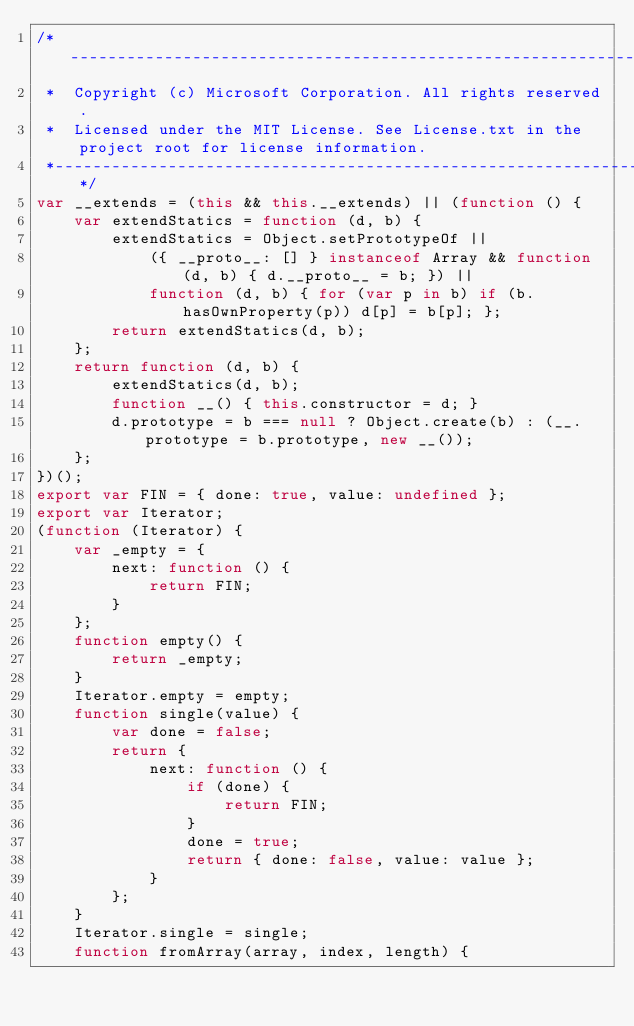<code> <loc_0><loc_0><loc_500><loc_500><_JavaScript_>/*---------------------------------------------------------------------------------------------
 *  Copyright (c) Microsoft Corporation. All rights reserved.
 *  Licensed under the MIT License. See License.txt in the project root for license information.
 *--------------------------------------------------------------------------------------------*/
var __extends = (this && this.__extends) || (function () {
    var extendStatics = function (d, b) {
        extendStatics = Object.setPrototypeOf ||
            ({ __proto__: [] } instanceof Array && function (d, b) { d.__proto__ = b; }) ||
            function (d, b) { for (var p in b) if (b.hasOwnProperty(p)) d[p] = b[p]; };
        return extendStatics(d, b);
    };
    return function (d, b) {
        extendStatics(d, b);
        function __() { this.constructor = d; }
        d.prototype = b === null ? Object.create(b) : (__.prototype = b.prototype, new __());
    };
})();
export var FIN = { done: true, value: undefined };
export var Iterator;
(function (Iterator) {
    var _empty = {
        next: function () {
            return FIN;
        }
    };
    function empty() {
        return _empty;
    }
    Iterator.empty = empty;
    function single(value) {
        var done = false;
        return {
            next: function () {
                if (done) {
                    return FIN;
                }
                done = true;
                return { done: false, value: value };
            }
        };
    }
    Iterator.single = single;
    function fromArray(array, index, length) {</code> 